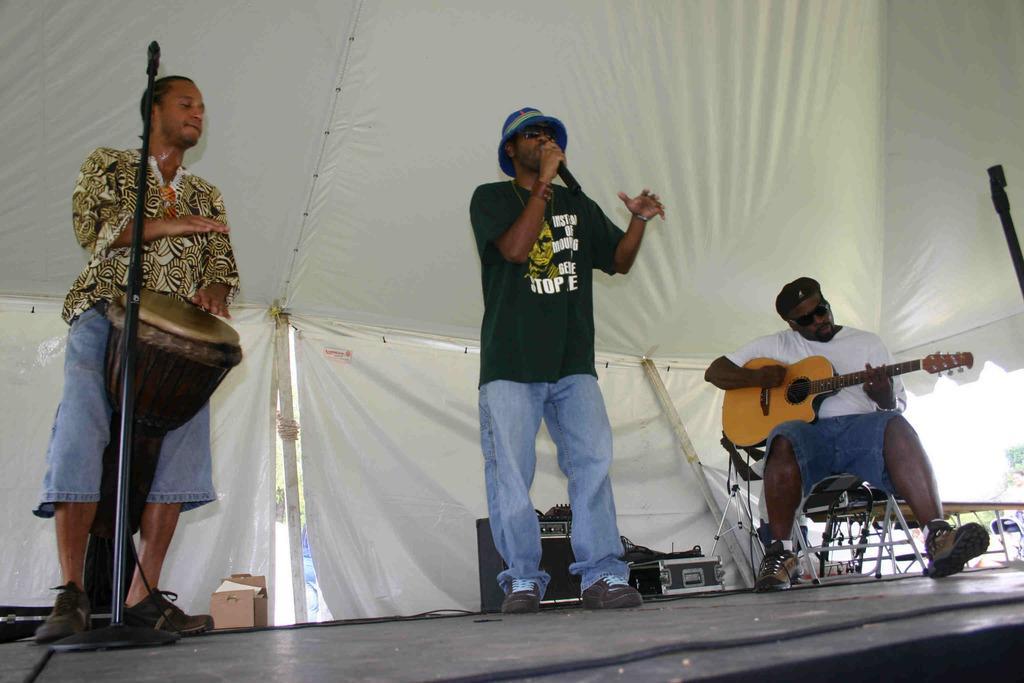Can you describe this image briefly? in this picture we have a man standing and singing a song in microphone ,another man standing and beating drums another man sitting and playing a guitar and in the back ground we have speakers , tent. 